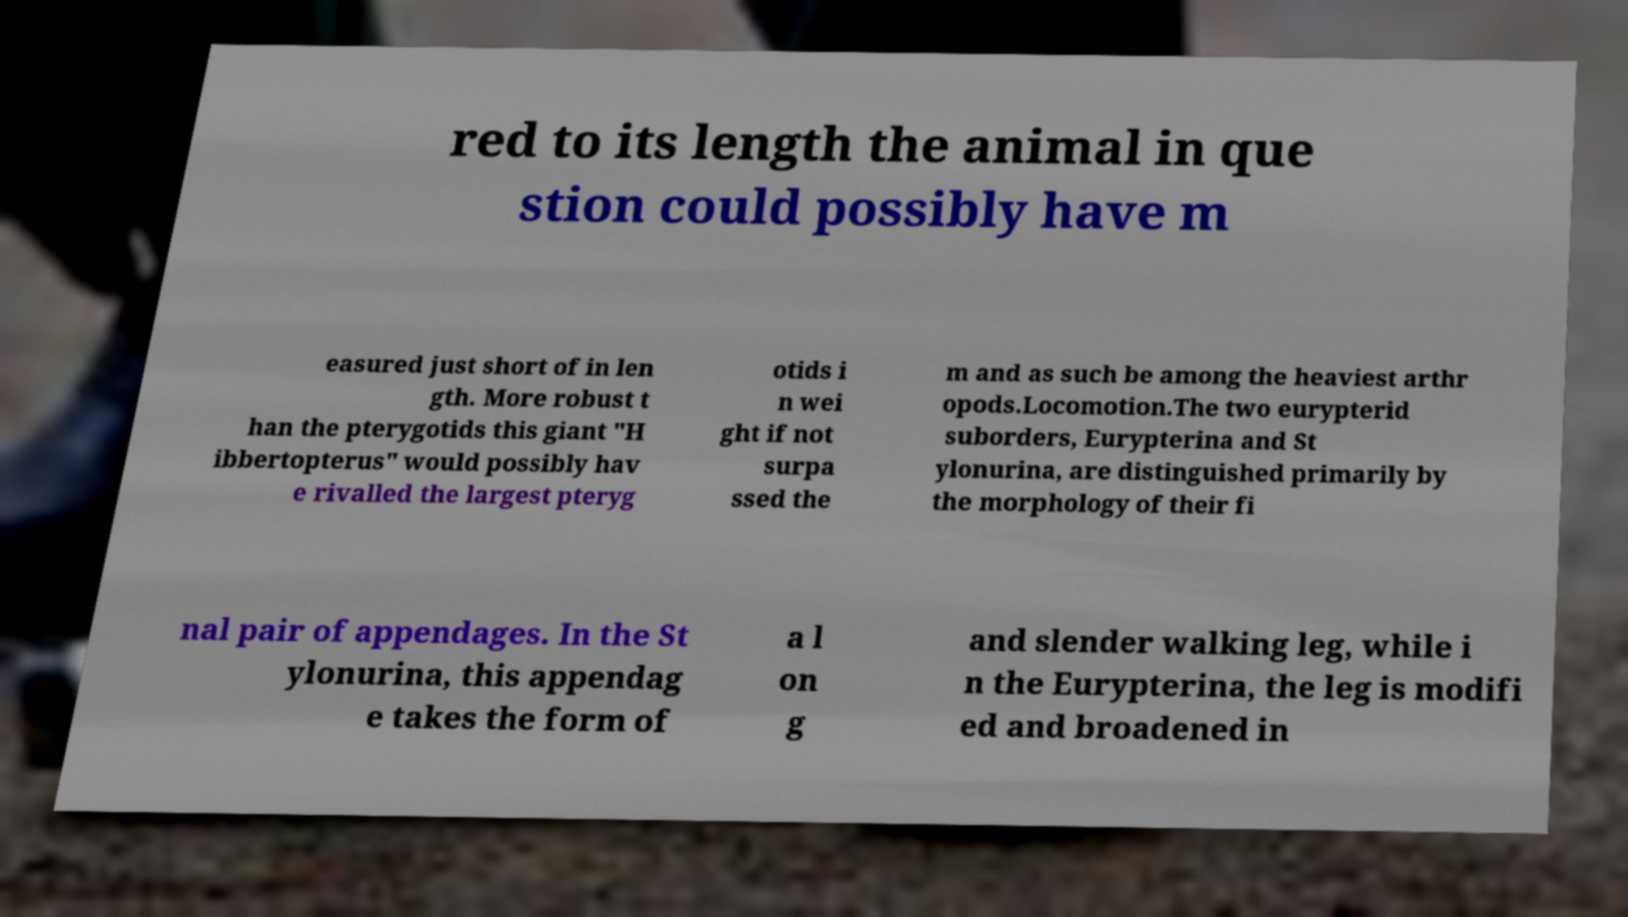Could you extract and type out the text from this image? red to its length the animal in que stion could possibly have m easured just short of in len gth. More robust t han the pterygotids this giant "H ibbertopterus" would possibly hav e rivalled the largest pteryg otids i n wei ght if not surpa ssed the m and as such be among the heaviest arthr opods.Locomotion.The two eurypterid suborders, Eurypterina and St ylonurina, are distinguished primarily by the morphology of their fi nal pair of appendages. In the St ylonurina, this appendag e takes the form of a l on g and slender walking leg, while i n the Eurypterina, the leg is modifi ed and broadened in 